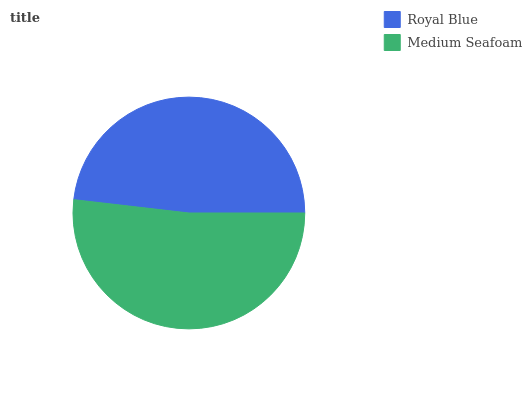Is Royal Blue the minimum?
Answer yes or no. Yes. Is Medium Seafoam the maximum?
Answer yes or no. Yes. Is Medium Seafoam the minimum?
Answer yes or no. No. Is Medium Seafoam greater than Royal Blue?
Answer yes or no. Yes. Is Royal Blue less than Medium Seafoam?
Answer yes or no. Yes. Is Royal Blue greater than Medium Seafoam?
Answer yes or no. No. Is Medium Seafoam less than Royal Blue?
Answer yes or no. No. Is Medium Seafoam the high median?
Answer yes or no. Yes. Is Royal Blue the low median?
Answer yes or no. Yes. Is Royal Blue the high median?
Answer yes or no. No. Is Medium Seafoam the low median?
Answer yes or no. No. 